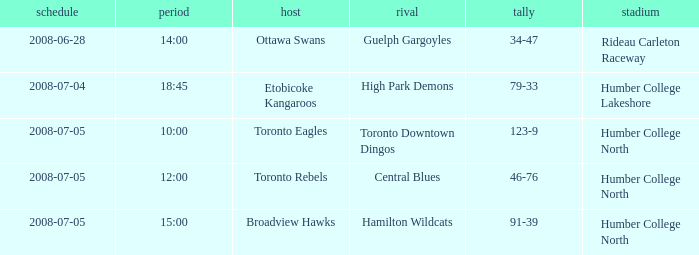What is the Date with a Time that is 18:45? 2008-07-04. 